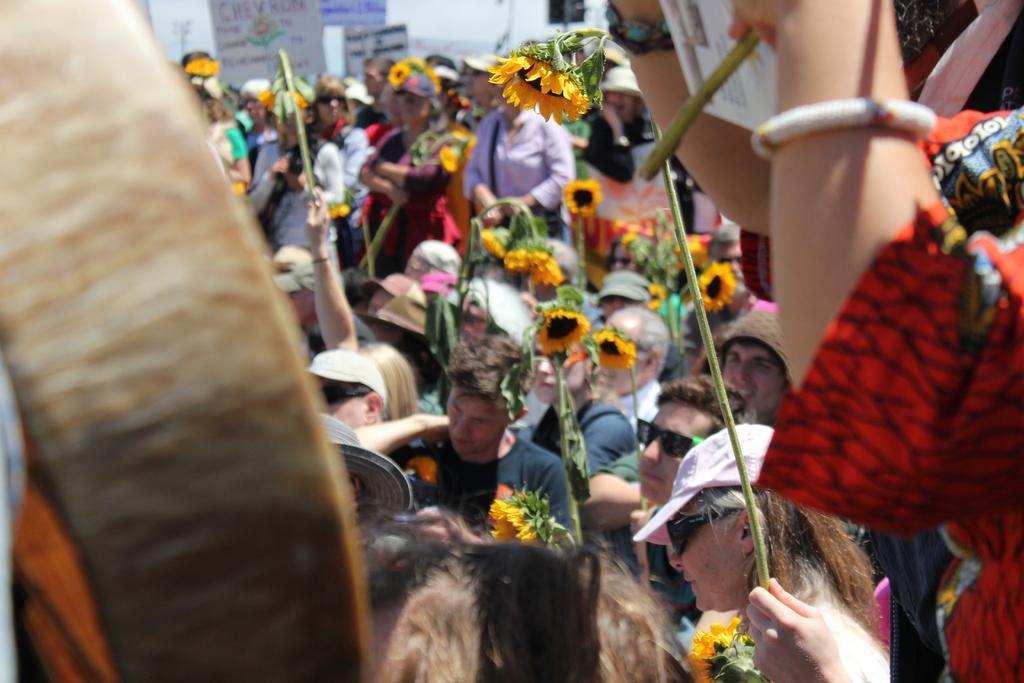Can you describe this image briefly? In this image we can see the people holding the sunflower flowers with the stems. We can also see some boards with the text. 